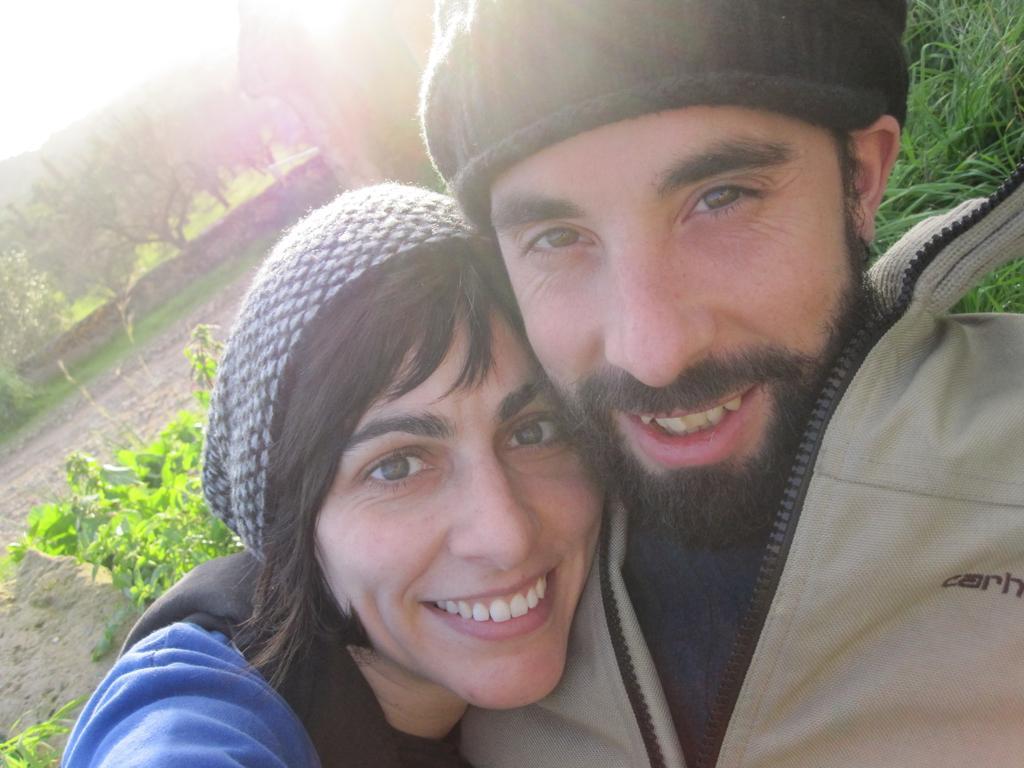In one or two sentences, can you explain what this image depicts? This picture about a man wearing grey jacket, cap smiling and giving a pose into the camera. Beside there is a woman wearing a blue jacket , smiling and giving a pose with the boy. In the background there are some plants. 